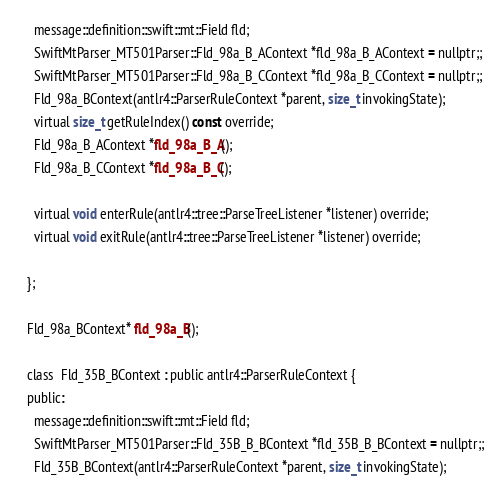<code> <loc_0><loc_0><loc_500><loc_500><_C_>    message::definition::swift::mt::Field fld;
    SwiftMtParser_MT501Parser::Fld_98a_B_AContext *fld_98a_B_AContext = nullptr;;
    SwiftMtParser_MT501Parser::Fld_98a_B_CContext *fld_98a_B_CContext = nullptr;;
    Fld_98a_BContext(antlr4::ParserRuleContext *parent, size_t invokingState);
    virtual size_t getRuleIndex() const override;
    Fld_98a_B_AContext *fld_98a_B_A();
    Fld_98a_B_CContext *fld_98a_B_C();

    virtual void enterRule(antlr4::tree::ParseTreeListener *listener) override;
    virtual void exitRule(antlr4::tree::ParseTreeListener *listener) override;
   
  };

  Fld_98a_BContext* fld_98a_B();

  class  Fld_35B_BContext : public antlr4::ParserRuleContext {
  public:
    message::definition::swift::mt::Field fld;
    SwiftMtParser_MT501Parser::Fld_35B_B_BContext *fld_35B_B_BContext = nullptr;;
    Fld_35B_BContext(antlr4::ParserRuleContext *parent, size_t invokingState);</code> 